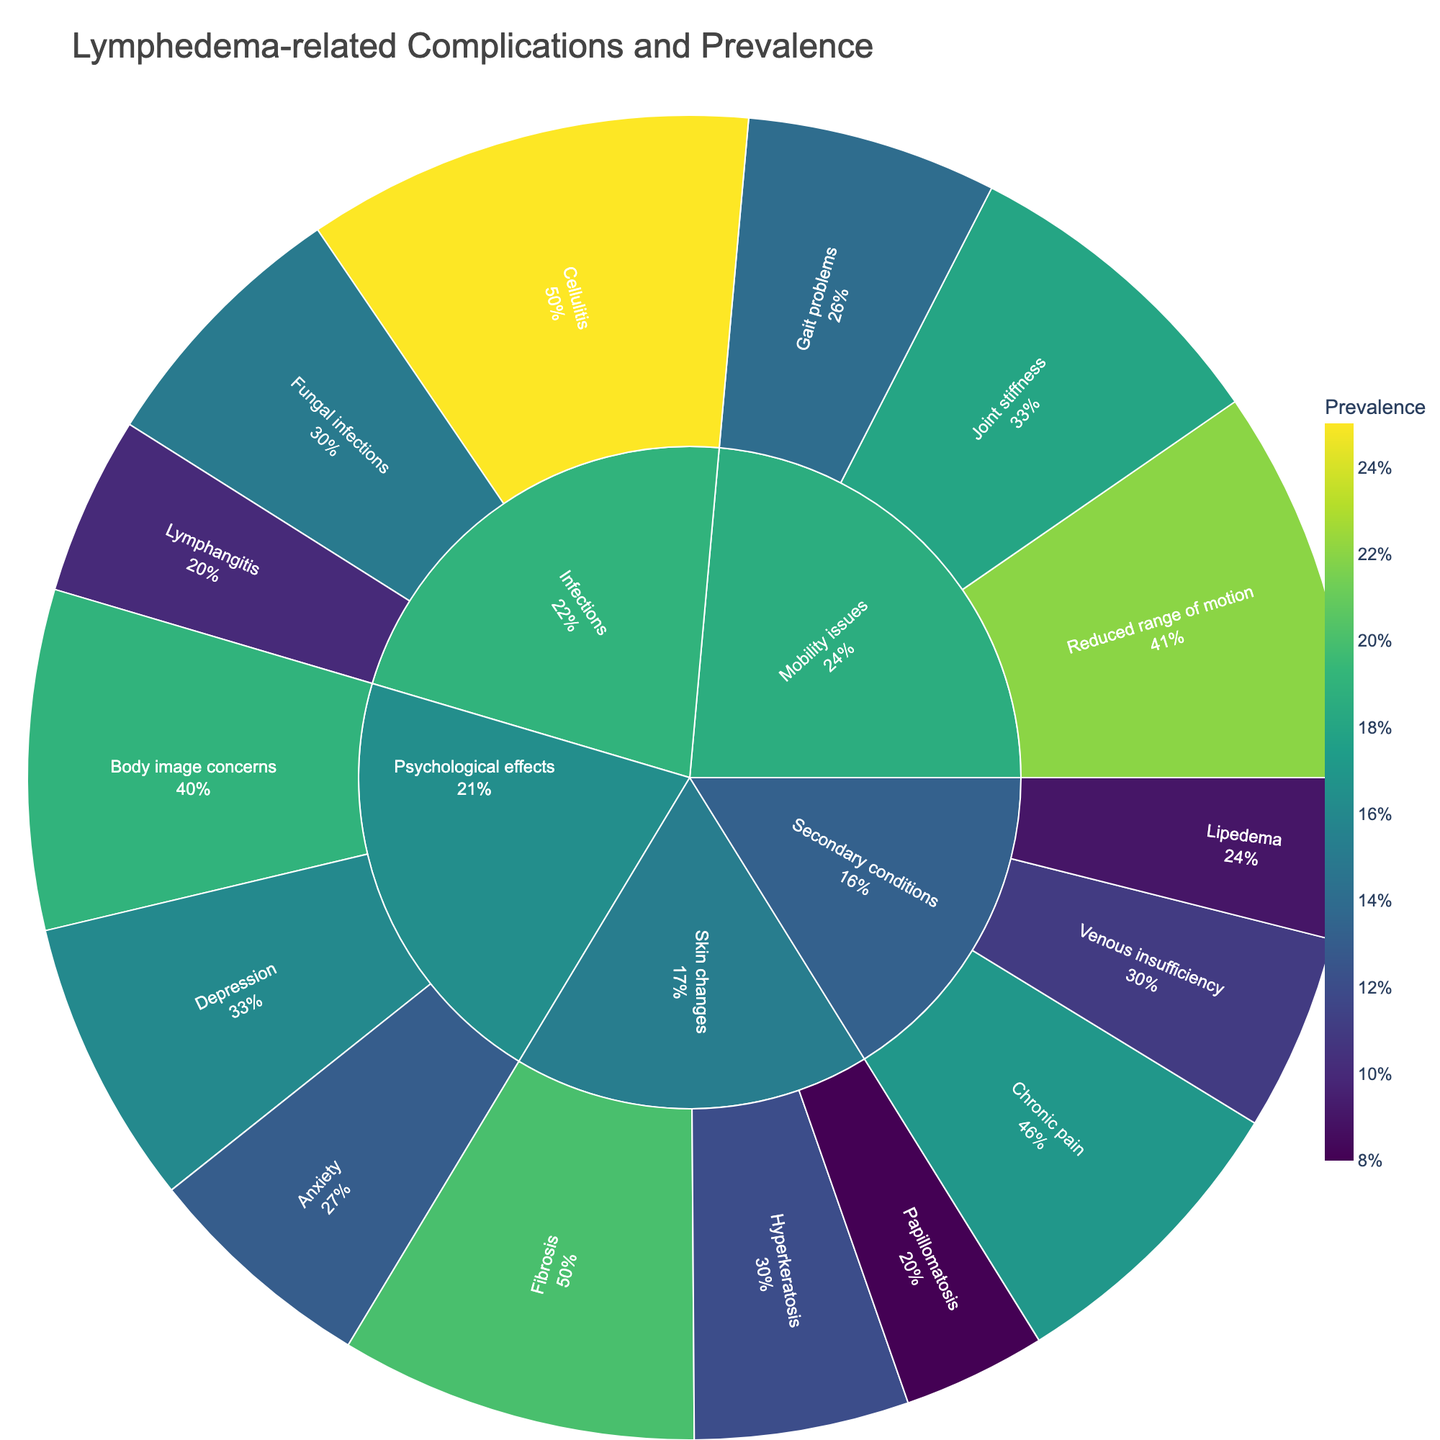What's the title of the plot? The title is usually displayed at the top of the plot. Here, it is specified in the code as "Lymphedema-related Complications and Prevalence".
Answer: Lymphedema-related Complications and Prevalence How many subcategories are there under 'Mobility issues'? To answer this, count the number of leaves under the 'Mobility issues' branch of the sunburst plot.
Answer: 3 Which subcategory under 'Infections' has the highest prevalence? Look at the prevalence percentages for each 'Infections' subcategory and identify the highest value. 'Cellulitis', 'Lymphangitis', and 'Fungal infections' have prevalences of 25, 10, and 15, respectively.
Answer: Cellulitis What is the combined prevalence of 'Depression' and 'Anxiety'? Sum the prevalence values of 'Depression' (16) and 'Anxiety' (13). 16 + 13 = 29.
Answer: 29 Which category has the most subcategories? Compare the number of subcategories under each main category. 'Infections' and 'Skin changes' both have 3 subcategories, but 'Psychological effects' also has 3, and 'Mobility issues' has 3 as well.
Answer: It's a tie Is the prevalence of 'Body image concerns' greater than 'Hyperkeratosis'? Compare the prevalence values directly. 'Body image concerns' has a prevalence of 19, while 'Hyperkeratosis' has 12. 19 is greater than 12.
Answer: Yes Which category shows the lowest prevalence for any of its subcategories? Examine the subcategories under each main category and identify the lowest value. 'Lipedema' under 'Secondary conditions' has the lowest prevalence of 9.
Answer: Secondary conditions What's the average prevalence of all subcategories under 'Skin changes'? Calculate the average by summing up prevalences of 'Fibrosis' (20), 'Hyperkeratosis' (12), and 'Papillomatosis' (8) and then divide by the number of subcategories (3): (20 + 12 + 8) / 3 = 40 / 3 ≈ 13.3.
Answer: 13.3 Which subcategory under 'Secondary conditions' has the lowest prevalence? Compare the prevalence values of 'Chronic pain' (17), 'Lipedema' (9), and 'Venous insufficiency' (11). 'Lipedema' has the lowest prevalence.
Answer: Lipedema Are there more subcategories under 'Psychological effects' or 'Secondary conditions'? Count the subcategories under 'Psychological effects' (3: Depression, Anxiety, Body image concerns) and 'Secondary conditions' (3: Chronic pain, Lipedema, Venous insufficiency).
Answer: Same number 